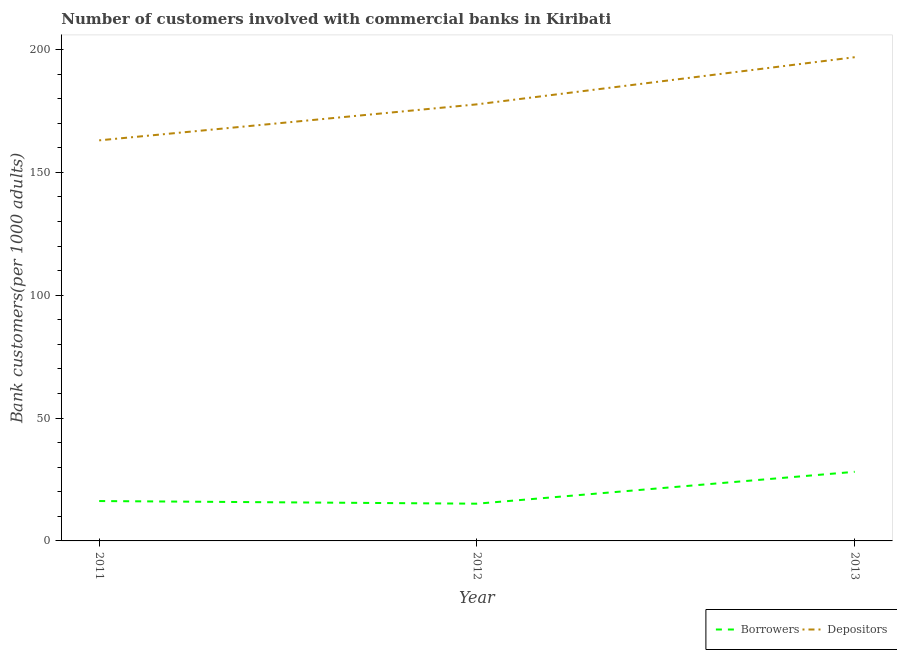How many different coloured lines are there?
Offer a terse response. 2. Does the line corresponding to number of depositors intersect with the line corresponding to number of borrowers?
Your answer should be very brief. No. Is the number of lines equal to the number of legend labels?
Your response must be concise. Yes. What is the number of depositors in 2013?
Offer a very short reply. 196.87. Across all years, what is the maximum number of borrowers?
Keep it short and to the point. 28.13. Across all years, what is the minimum number of borrowers?
Make the answer very short. 15.15. In which year was the number of borrowers maximum?
Your response must be concise. 2013. In which year was the number of borrowers minimum?
Offer a terse response. 2012. What is the total number of depositors in the graph?
Give a very brief answer. 537.59. What is the difference between the number of borrowers in 2011 and that in 2012?
Provide a succinct answer. 1.08. What is the difference between the number of depositors in 2012 and the number of borrowers in 2013?
Make the answer very short. 149.56. What is the average number of borrowers per year?
Give a very brief answer. 19.84. In the year 2012, what is the difference between the number of borrowers and number of depositors?
Ensure brevity in your answer.  -162.53. What is the ratio of the number of borrowers in 2012 to that in 2013?
Provide a short and direct response. 0.54. Is the number of depositors in 2012 less than that in 2013?
Your response must be concise. Yes. Is the difference between the number of depositors in 2011 and 2013 greater than the difference between the number of borrowers in 2011 and 2013?
Your response must be concise. No. What is the difference between the highest and the second highest number of depositors?
Keep it short and to the point. 19.19. What is the difference between the highest and the lowest number of borrowers?
Ensure brevity in your answer.  12.98. Does the number of borrowers monotonically increase over the years?
Provide a short and direct response. No. Is the number of borrowers strictly greater than the number of depositors over the years?
Give a very brief answer. No. How many lines are there?
Your answer should be compact. 2. Does the graph contain any zero values?
Your response must be concise. No. Does the graph contain grids?
Make the answer very short. No. Where does the legend appear in the graph?
Give a very brief answer. Bottom right. How are the legend labels stacked?
Provide a short and direct response. Horizontal. What is the title of the graph?
Give a very brief answer. Number of customers involved with commercial banks in Kiribati. Does "Measles" appear as one of the legend labels in the graph?
Your answer should be very brief. No. What is the label or title of the X-axis?
Provide a succinct answer. Year. What is the label or title of the Y-axis?
Offer a very short reply. Bank customers(per 1000 adults). What is the Bank customers(per 1000 adults) in Borrowers in 2011?
Provide a succinct answer. 16.23. What is the Bank customers(per 1000 adults) of Depositors in 2011?
Make the answer very short. 163.03. What is the Bank customers(per 1000 adults) in Borrowers in 2012?
Provide a succinct answer. 15.15. What is the Bank customers(per 1000 adults) of Depositors in 2012?
Your answer should be very brief. 177.69. What is the Bank customers(per 1000 adults) in Borrowers in 2013?
Ensure brevity in your answer.  28.13. What is the Bank customers(per 1000 adults) of Depositors in 2013?
Your answer should be compact. 196.87. Across all years, what is the maximum Bank customers(per 1000 adults) of Borrowers?
Ensure brevity in your answer.  28.13. Across all years, what is the maximum Bank customers(per 1000 adults) in Depositors?
Ensure brevity in your answer.  196.87. Across all years, what is the minimum Bank customers(per 1000 adults) of Borrowers?
Provide a short and direct response. 15.15. Across all years, what is the minimum Bank customers(per 1000 adults) of Depositors?
Your answer should be very brief. 163.03. What is the total Bank customers(per 1000 adults) in Borrowers in the graph?
Provide a short and direct response. 59.51. What is the total Bank customers(per 1000 adults) in Depositors in the graph?
Keep it short and to the point. 537.59. What is the difference between the Bank customers(per 1000 adults) of Borrowers in 2011 and that in 2012?
Offer a terse response. 1.08. What is the difference between the Bank customers(per 1000 adults) in Depositors in 2011 and that in 2012?
Make the answer very short. -14.66. What is the difference between the Bank customers(per 1000 adults) of Borrowers in 2011 and that in 2013?
Your answer should be compact. -11.9. What is the difference between the Bank customers(per 1000 adults) in Depositors in 2011 and that in 2013?
Offer a very short reply. -33.84. What is the difference between the Bank customers(per 1000 adults) in Borrowers in 2012 and that in 2013?
Ensure brevity in your answer.  -12.98. What is the difference between the Bank customers(per 1000 adults) in Depositors in 2012 and that in 2013?
Offer a terse response. -19.19. What is the difference between the Bank customers(per 1000 adults) of Borrowers in 2011 and the Bank customers(per 1000 adults) of Depositors in 2012?
Keep it short and to the point. -161.46. What is the difference between the Bank customers(per 1000 adults) of Borrowers in 2011 and the Bank customers(per 1000 adults) of Depositors in 2013?
Your response must be concise. -180.64. What is the difference between the Bank customers(per 1000 adults) in Borrowers in 2012 and the Bank customers(per 1000 adults) in Depositors in 2013?
Offer a terse response. -181.72. What is the average Bank customers(per 1000 adults) in Borrowers per year?
Provide a short and direct response. 19.84. What is the average Bank customers(per 1000 adults) in Depositors per year?
Your answer should be very brief. 179.2. In the year 2011, what is the difference between the Bank customers(per 1000 adults) of Borrowers and Bank customers(per 1000 adults) of Depositors?
Your answer should be compact. -146.8. In the year 2012, what is the difference between the Bank customers(per 1000 adults) in Borrowers and Bank customers(per 1000 adults) in Depositors?
Your answer should be compact. -162.53. In the year 2013, what is the difference between the Bank customers(per 1000 adults) of Borrowers and Bank customers(per 1000 adults) of Depositors?
Your answer should be compact. -168.75. What is the ratio of the Bank customers(per 1000 adults) in Borrowers in 2011 to that in 2012?
Give a very brief answer. 1.07. What is the ratio of the Bank customers(per 1000 adults) in Depositors in 2011 to that in 2012?
Make the answer very short. 0.92. What is the ratio of the Bank customers(per 1000 adults) in Borrowers in 2011 to that in 2013?
Offer a terse response. 0.58. What is the ratio of the Bank customers(per 1000 adults) in Depositors in 2011 to that in 2013?
Ensure brevity in your answer.  0.83. What is the ratio of the Bank customers(per 1000 adults) of Borrowers in 2012 to that in 2013?
Provide a succinct answer. 0.54. What is the ratio of the Bank customers(per 1000 adults) in Depositors in 2012 to that in 2013?
Give a very brief answer. 0.9. What is the difference between the highest and the second highest Bank customers(per 1000 adults) in Borrowers?
Offer a very short reply. 11.9. What is the difference between the highest and the second highest Bank customers(per 1000 adults) in Depositors?
Keep it short and to the point. 19.19. What is the difference between the highest and the lowest Bank customers(per 1000 adults) of Borrowers?
Offer a very short reply. 12.98. What is the difference between the highest and the lowest Bank customers(per 1000 adults) of Depositors?
Offer a terse response. 33.84. 